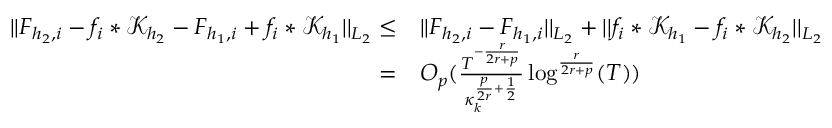<formula> <loc_0><loc_0><loc_500><loc_500>\begin{array} { r l } { | | F _ { { h _ { 2 } } , i } - f _ { i } * \mathcal { K } _ { h _ { 2 } } - F _ { { h _ { 1 } } , i } + f _ { i } * \mathcal { K } _ { h _ { 1 } } | | _ { L _ { 2 } } \leq } & { | | F _ { { h _ { 2 } } , i } - F _ { { h _ { 1 } } , i } | | _ { L _ { 2 } } + | | f _ { i } * \mathcal { K } _ { h _ { 1 } } - f _ { i } * \mathcal { K } _ { h _ { 2 } } | | _ { L _ { 2 } } } \\ { = } & { O _ { p } ( \frac { T ^ { - \frac { r } { 2 r + p } } } { \kappa _ { k } ^ { \frac { p } { 2 r } + \frac { 1 } { 2 } } } \log ^ { \frac { r } { 2 r + p } } ( T ) ) } \end{array}</formula> 